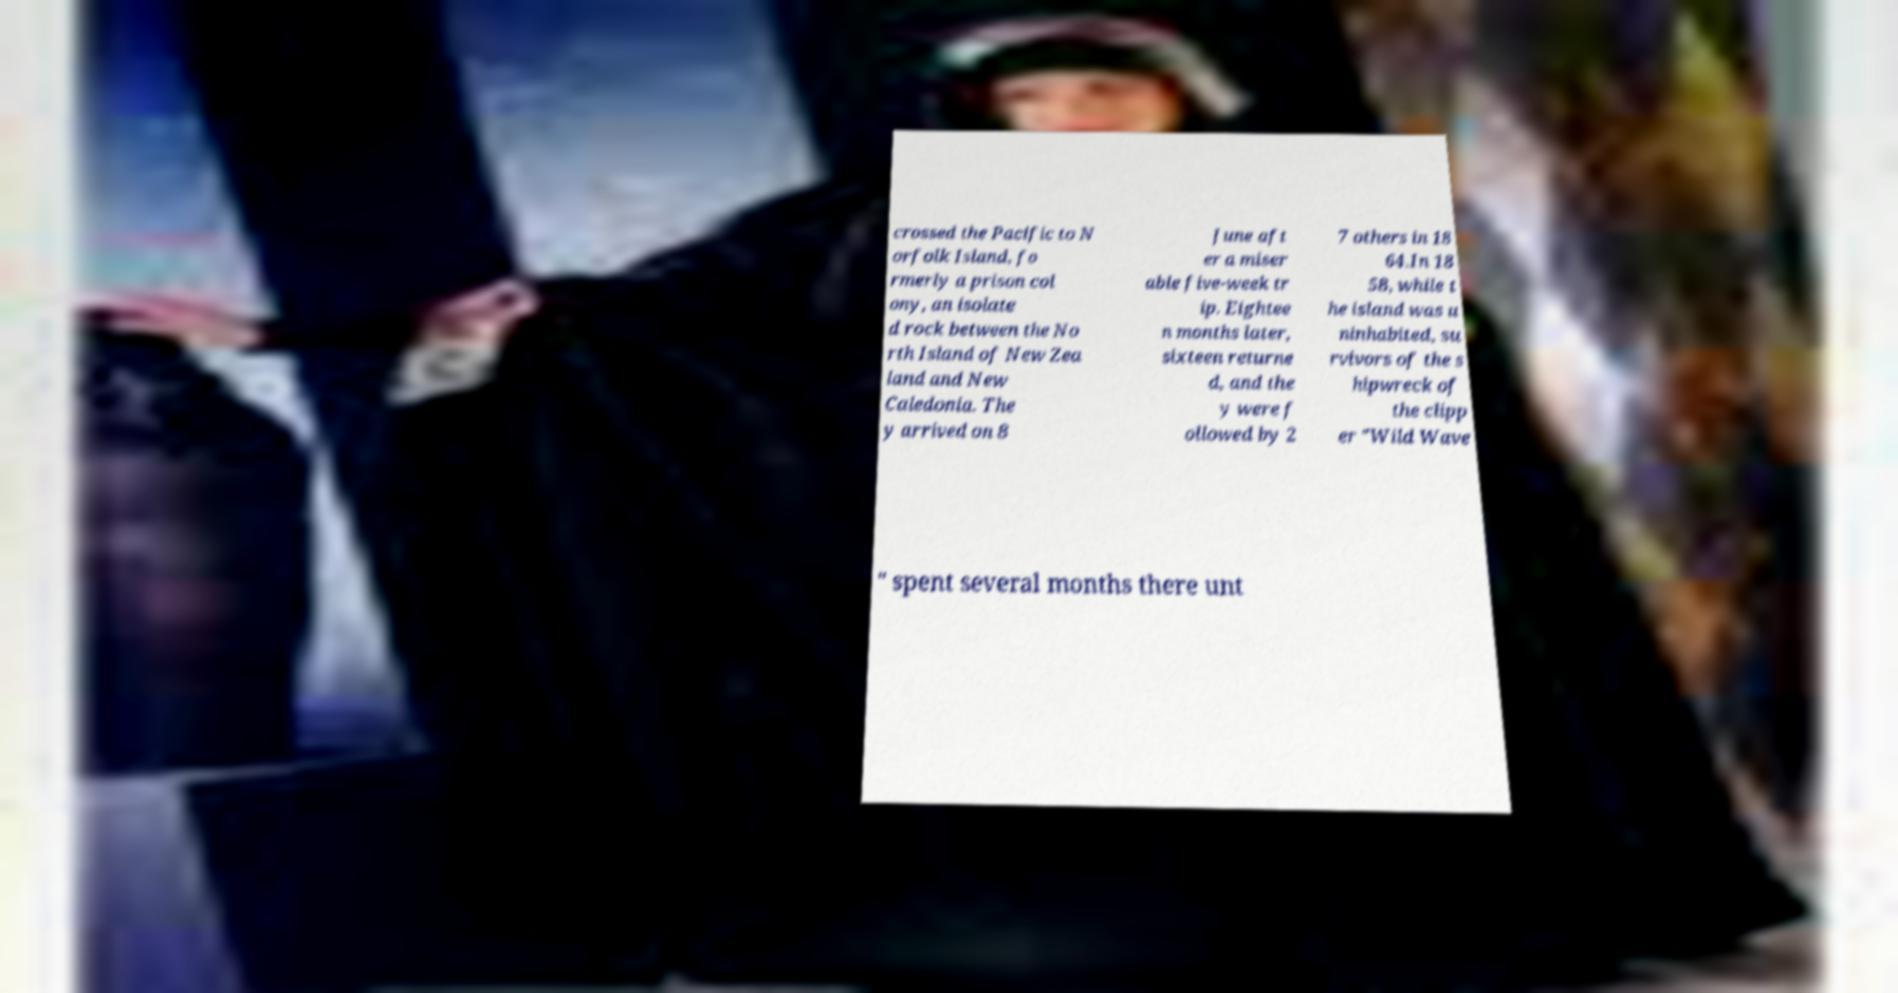Could you extract and type out the text from this image? crossed the Pacific to N orfolk Island, fo rmerly a prison col ony, an isolate d rock between the No rth Island of New Zea land and New Caledonia. The y arrived on 8 June aft er a miser able five-week tr ip. Eightee n months later, sixteen returne d, and the y were f ollowed by 2 7 others in 18 64.In 18 58, while t he island was u ninhabited, su rvivors of the s hipwreck of the clipp er "Wild Wave " spent several months there unt 